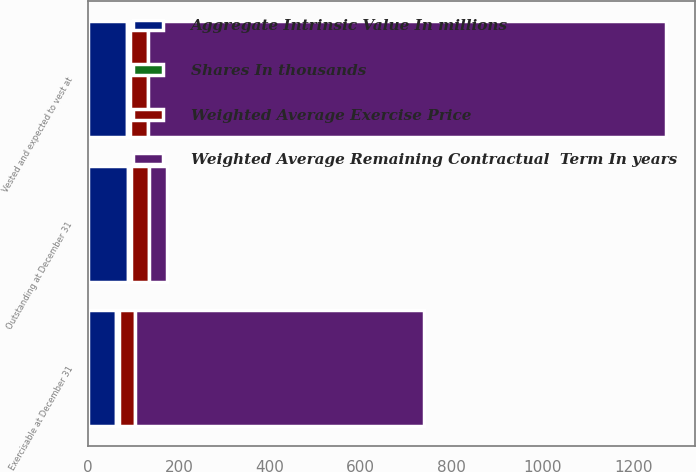<chart> <loc_0><loc_0><loc_500><loc_500><stacked_bar_chart><ecel><fcel>Outstanding at December 31<fcel>Vested and expected to vest at<fcel>Exercisable at December 31<nl><fcel>Weighted Average Remaining Contractual  Term In years<fcel>40<fcel>1140<fcel>636<nl><fcel>Aggregate Intrinsic Value In millions<fcel>87.64<fcel>86.64<fcel>62.62<nl><fcel>Shares In thousands<fcel>6.6<fcel>6.6<fcel>4.9<nl><fcel>Weighted Average Exercise Price<fcel>40<fcel>39.5<fcel>35.9<nl></chart> 